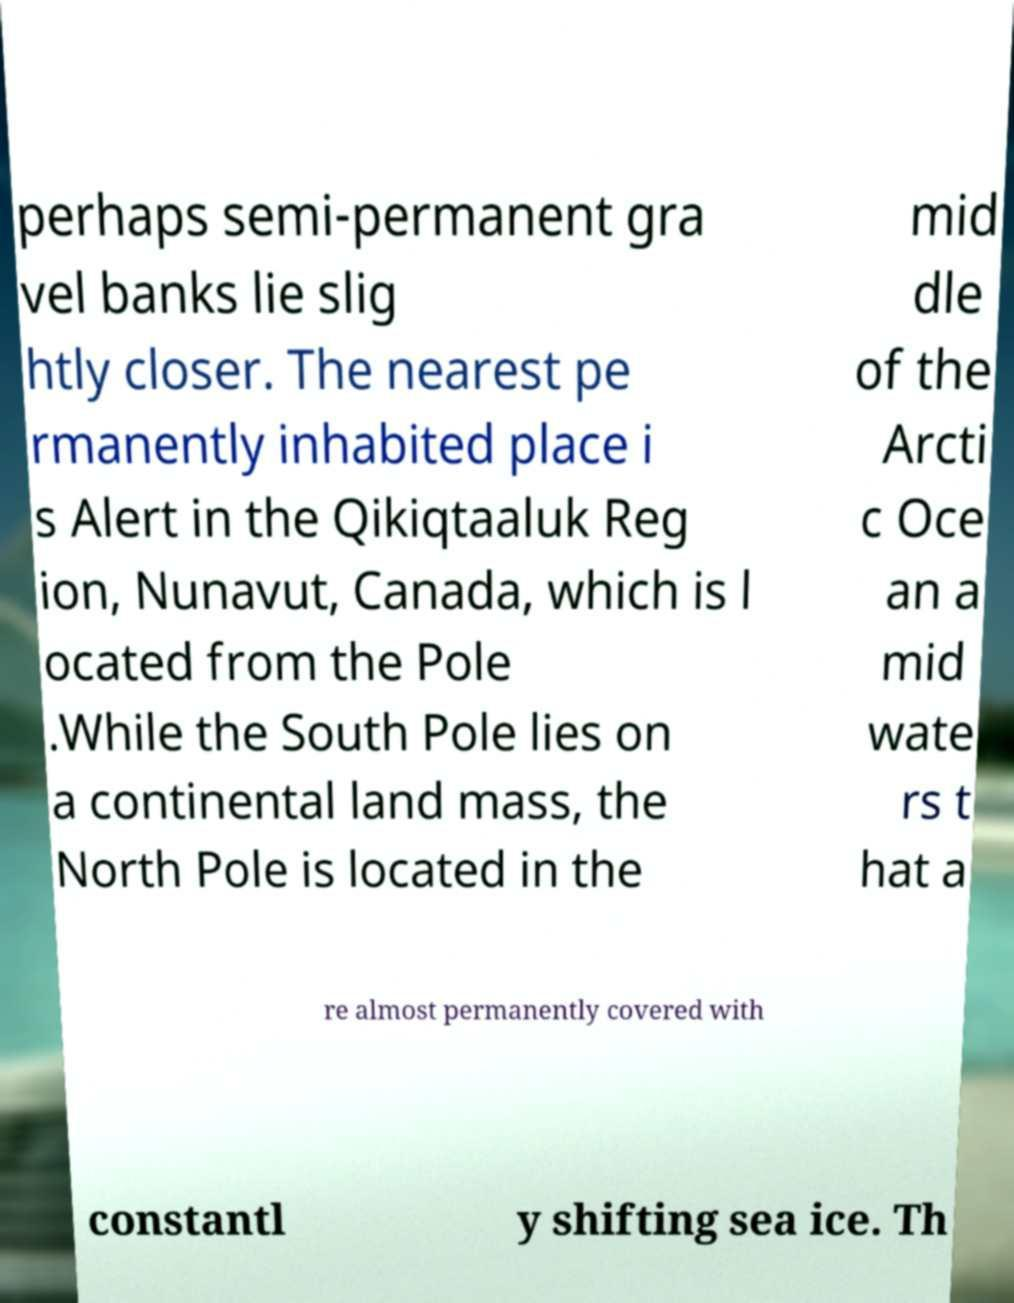Can you read and provide the text displayed in the image?This photo seems to have some interesting text. Can you extract and type it out for me? perhaps semi-permanent gra vel banks lie slig htly closer. The nearest pe rmanently inhabited place i s Alert in the Qikiqtaaluk Reg ion, Nunavut, Canada, which is l ocated from the Pole .While the South Pole lies on a continental land mass, the North Pole is located in the mid dle of the Arcti c Oce an a mid wate rs t hat a re almost permanently covered with constantl y shifting sea ice. Th 